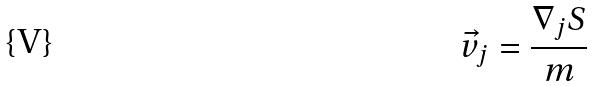Convert formula to latex. <formula><loc_0><loc_0><loc_500><loc_500>\vec { v } _ { j } = \frac { \nabla _ { j } S } { m }</formula> 